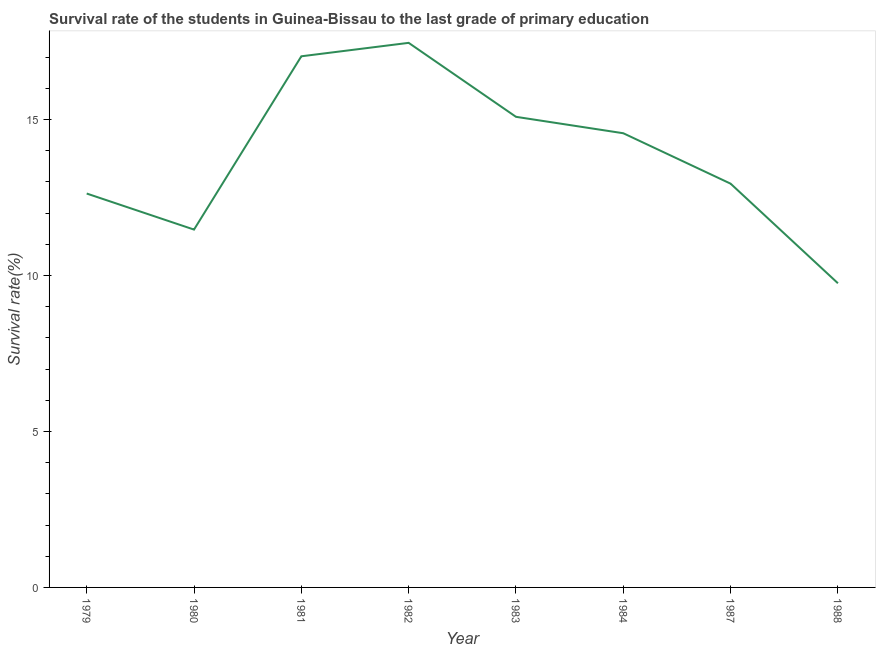What is the survival rate in primary education in 1987?
Your answer should be compact. 12.94. Across all years, what is the maximum survival rate in primary education?
Your answer should be very brief. 17.45. Across all years, what is the minimum survival rate in primary education?
Ensure brevity in your answer.  9.75. In which year was the survival rate in primary education maximum?
Keep it short and to the point. 1982. What is the sum of the survival rate in primary education?
Keep it short and to the point. 110.9. What is the difference between the survival rate in primary education in 1979 and 1983?
Your answer should be very brief. -2.46. What is the average survival rate in primary education per year?
Your answer should be compact. 13.86. What is the median survival rate in primary education?
Your response must be concise. 13.75. What is the ratio of the survival rate in primary education in 1980 to that in 1988?
Give a very brief answer. 1.18. Is the survival rate in primary education in 1980 less than that in 1988?
Your answer should be compact. No. What is the difference between the highest and the second highest survival rate in primary education?
Keep it short and to the point. 0.43. What is the difference between the highest and the lowest survival rate in primary education?
Give a very brief answer. 7.71. Does the survival rate in primary education monotonically increase over the years?
Offer a terse response. No. What is the difference between two consecutive major ticks on the Y-axis?
Keep it short and to the point. 5. Are the values on the major ticks of Y-axis written in scientific E-notation?
Give a very brief answer. No. Does the graph contain any zero values?
Your response must be concise. No. What is the title of the graph?
Offer a very short reply. Survival rate of the students in Guinea-Bissau to the last grade of primary education. What is the label or title of the X-axis?
Your response must be concise. Year. What is the label or title of the Y-axis?
Give a very brief answer. Survival rate(%). What is the Survival rate(%) in 1979?
Provide a succinct answer. 12.62. What is the Survival rate(%) in 1980?
Make the answer very short. 11.47. What is the Survival rate(%) of 1981?
Ensure brevity in your answer.  17.02. What is the Survival rate(%) of 1982?
Your response must be concise. 17.45. What is the Survival rate(%) in 1983?
Ensure brevity in your answer.  15.08. What is the Survival rate(%) of 1984?
Your response must be concise. 14.56. What is the Survival rate(%) in 1987?
Your answer should be compact. 12.94. What is the Survival rate(%) in 1988?
Your answer should be compact. 9.75. What is the difference between the Survival rate(%) in 1979 and 1980?
Provide a short and direct response. 1.16. What is the difference between the Survival rate(%) in 1979 and 1981?
Your answer should be compact. -4.4. What is the difference between the Survival rate(%) in 1979 and 1982?
Offer a terse response. -4.83. What is the difference between the Survival rate(%) in 1979 and 1983?
Your answer should be very brief. -2.46. What is the difference between the Survival rate(%) in 1979 and 1984?
Your answer should be compact. -1.93. What is the difference between the Survival rate(%) in 1979 and 1987?
Make the answer very short. -0.32. What is the difference between the Survival rate(%) in 1979 and 1988?
Offer a very short reply. 2.88. What is the difference between the Survival rate(%) in 1980 and 1981?
Provide a succinct answer. -5.55. What is the difference between the Survival rate(%) in 1980 and 1982?
Your answer should be very brief. -5.99. What is the difference between the Survival rate(%) in 1980 and 1983?
Provide a succinct answer. -3.61. What is the difference between the Survival rate(%) in 1980 and 1984?
Your response must be concise. -3.09. What is the difference between the Survival rate(%) in 1980 and 1987?
Offer a very short reply. -1.47. What is the difference between the Survival rate(%) in 1980 and 1988?
Make the answer very short. 1.72. What is the difference between the Survival rate(%) in 1981 and 1982?
Your answer should be compact. -0.43. What is the difference between the Survival rate(%) in 1981 and 1983?
Provide a short and direct response. 1.94. What is the difference between the Survival rate(%) in 1981 and 1984?
Make the answer very short. 2.47. What is the difference between the Survival rate(%) in 1981 and 1987?
Make the answer very short. 4.08. What is the difference between the Survival rate(%) in 1981 and 1988?
Your answer should be compact. 7.27. What is the difference between the Survival rate(%) in 1982 and 1983?
Ensure brevity in your answer.  2.37. What is the difference between the Survival rate(%) in 1982 and 1984?
Offer a terse response. 2.9. What is the difference between the Survival rate(%) in 1982 and 1987?
Give a very brief answer. 4.51. What is the difference between the Survival rate(%) in 1982 and 1988?
Offer a very short reply. 7.71. What is the difference between the Survival rate(%) in 1983 and 1984?
Give a very brief answer. 0.53. What is the difference between the Survival rate(%) in 1983 and 1987?
Your answer should be compact. 2.14. What is the difference between the Survival rate(%) in 1983 and 1988?
Keep it short and to the point. 5.33. What is the difference between the Survival rate(%) in 1984 and 1987?
Give a very brief answer. 1.62. What is the difference between the Survival rate(%) in 1984 and 1988?
Make the answer very short. 4.81. What is the difference between the Survival rate(%) in 1987 and 1988?
Provide a succinct answer. 3.19. What is the ratio of the Survival rate(%) in 1979 to that in 1980?
Provide a succinct answer. 1.1. What is the ratio of the Survival rate(%) in 1979 to that in 1981?
Provide a succinct answer. 0.74. What is the ratio of the Survival rate(%) in 1979 to that in 1982?
Keep it short and to the point. 0.72. What is the ratio of the Survival rate(%) in 1979 to that in 1983?
Your answer should be compact. 0.84. What is the ratio of the Survival rate(%) in 1979 to that in 1984?
Give a very brief answer. 0.87. What is the ratio of the Survival rate(%) in 1979 to that in 1988?
Ensure brevity in your answer.  1.29. What is the ratio of the Survival rate(%) in 1980 to that in 1981?
Keep it short and to the point. 0.67. What is the ratio of the Survival rate(%) in 1980 to that in 1982?
Give a very brief answer. 0.66. What is the ratio of the Survival rate(%) in 1980 to that in 1983?
Your answer should be very brief. 0.76. What is the ratio of the Survival rate(%) in 1980 to that in 1984?
Offer a very short reply. 0.79. What is the ratio of the Survival rate(%) in 1980 to that in 1987?
Provide a succinct answer. 0.89. What is the ratio of the Survival rate(%) in 1980 to that in 1988?
Provide a succinct answer. 1.18. What is the ratio of the Survival rate(%) in 1981 to that in 1982?
Make the answer very short. 0.97. What is the ratio of the Survival rate(%) in 1981 to that in 1983?
Your answer should be compact. 1.13. What is the ratio of the Survival rate(%) in 1981 to that in 1984?
Keep it short and to the point. 1.17. What is the ratio of the Survival rate(%) in 1981 to that in 1987?
Provide a succinct answer. 1.31. What is the ratio of the Survival rate(%) in 1981 to that in 1988?
Give a very brief answer. 1.75. What is the ratio of the Survival rate(%) in 1982 to that in 1983?
Provide a short and direct response. 1.16. What is the ratio of the Survival rate(%) in 1982 to that in 1984?
Your answer should be compact. 1.2. What is the ratio of the Survival rate(%) in 1982 to that in 1987?
Your answer should be compact. 1.35. What is the ratio of the Survival rate(%) in 1982 to that in 1988?
Offer a very short reply. 1.79. What is the ratio of the Survival rate(%) in 1983 to that in 1984?
Provide a short and direct response. 1.04. What is the ratio of the Survival rate(%) in 1983 to that in 1987?
Your answer should be compact. 1.17. What is the ratio of the Survival rate(%) in 1983 to that in 1988?
Your answer should be compact. 1.55. What is the ratio of the Survival rate(%) in 1984 to that in 1987?
Your answer should be compact. 1.12. What is the ratio of the Survival rate(%) in 1984 to that in 1988?
Make the answer very short. 1.49. What is the ratio of the Survival rate(%) in 1987 to that in 1988?
Keep it short and to the point. 1.33. 